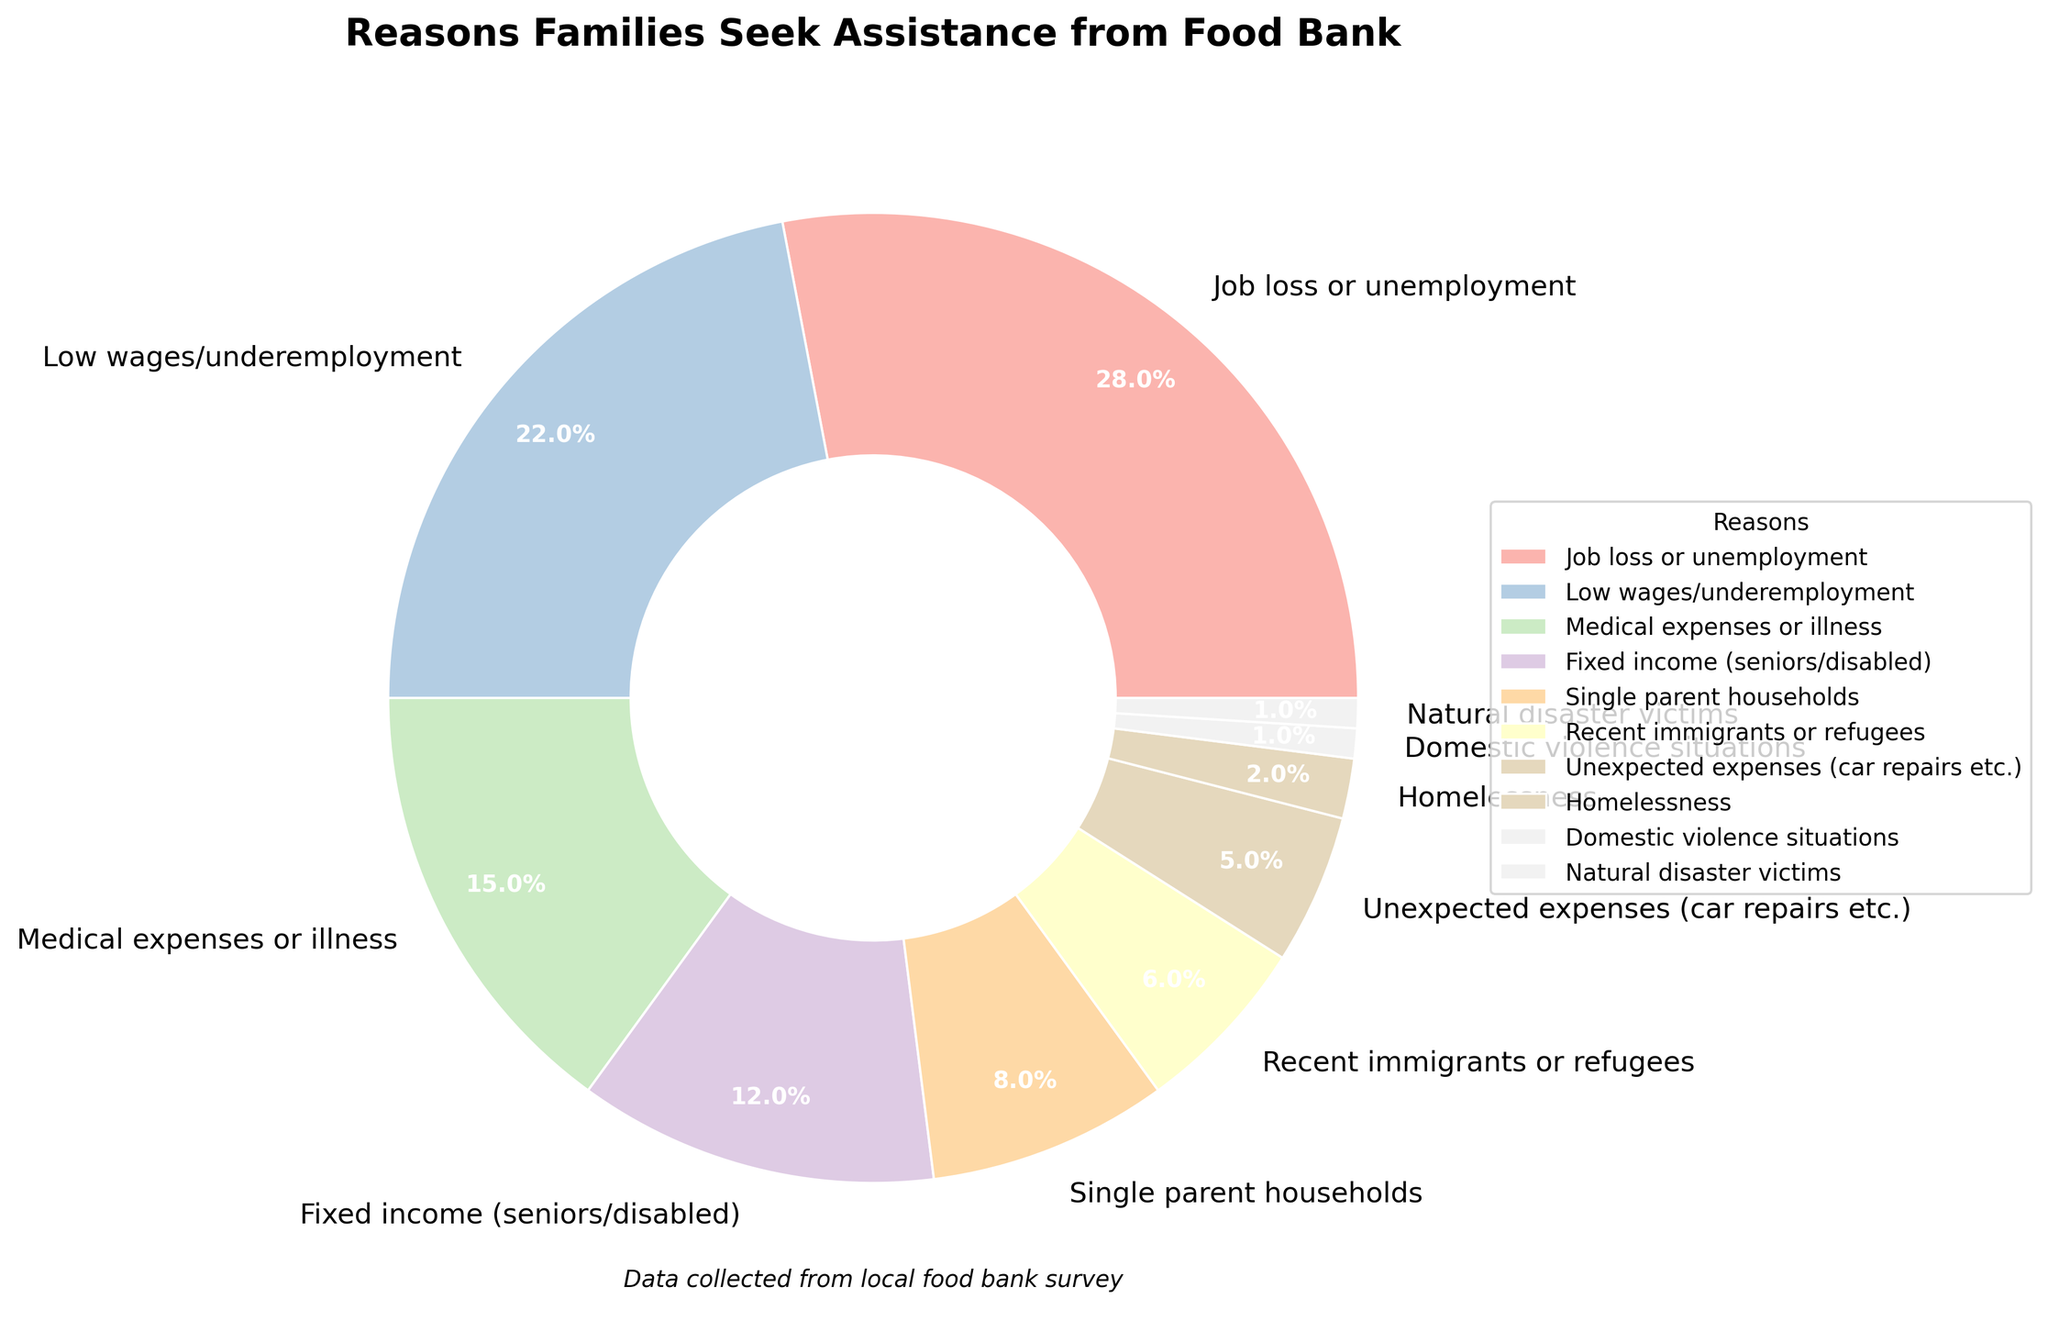Which reason has the highest percentage of families seeking assistance? The reason with the highest percentage is the largest slice in the pie chart. "Job loss or unemployment" has the largest slice.
Answer: Job loss or unemployment What is the total percentage of families seeking assistance due to medical expenses or illness and low wages/underemployment? Add the percentages for both reasons: 15% (medical expenses or illness) and 22% (low wages/underemployment). Total is 15% + 22%.
Answer: 37% Is the percentage of families seeking assistance due to homelessness greater than the percentage due to unexpected expenses (car repairs etc.)? Compare the percentage for homelessness (2%) to the percentage for unexpected expenses (5%). 2% is less than 5%.
Answer: No What is the combined percentage of families seeking assistance for reasons related to economic conditions (job loss or unemployment and low wages/underemployment)? Add the percentages for both reasons: 28% (job loss or unemployment) and 22% (low wages/underemployment). Total is 28% + 22%.
Answer: 50% Which reason has the smallest percentage of families seeking assistance? The smallest slice in the pie chart represents the reason with the smallest percentage. "Domestic violence situations" and "Natural disaster victims," both have the smallest slice.
Answer: Domestic violence situations and Natural disaster victims What is the percentage difference between families seeking assistance due to single parent households and those due to fixed income (seniors/disabled)? Subtract the percentage for single parent households (8%) from the percentage for fixed income (12%). Difference is 12% - 8%.
Answer: 4% Which two reasons have the closest percentages, and what are those percentages? Compare the percentages of each reason to find the two closest values: Natural disaster victims (1%) and Domestic violence situations (1%).
Answer: Natural disaster victims and Domestic violence situations - 1% How does the percentage of families seeking assistance due to recent immigrants or refugees compare with those due to medical expenses or illness? Compare the percentage for recent immigrants or refugees (6%) to the percentage for medical expenses or illness (15%). 6% is less than 15%.
Answer: Less What is the average percentage of families seeking assistance due to job loss or unemployment, low wages/underemployment, and medical expenses or illness? Add the percentages for these three reasons: 28% (job loss), 22% (low wages), and 15% (medical expenses). Sum is 28% + 22% + 15% = 65%. Divide by 3.
Answer: 21.67% 